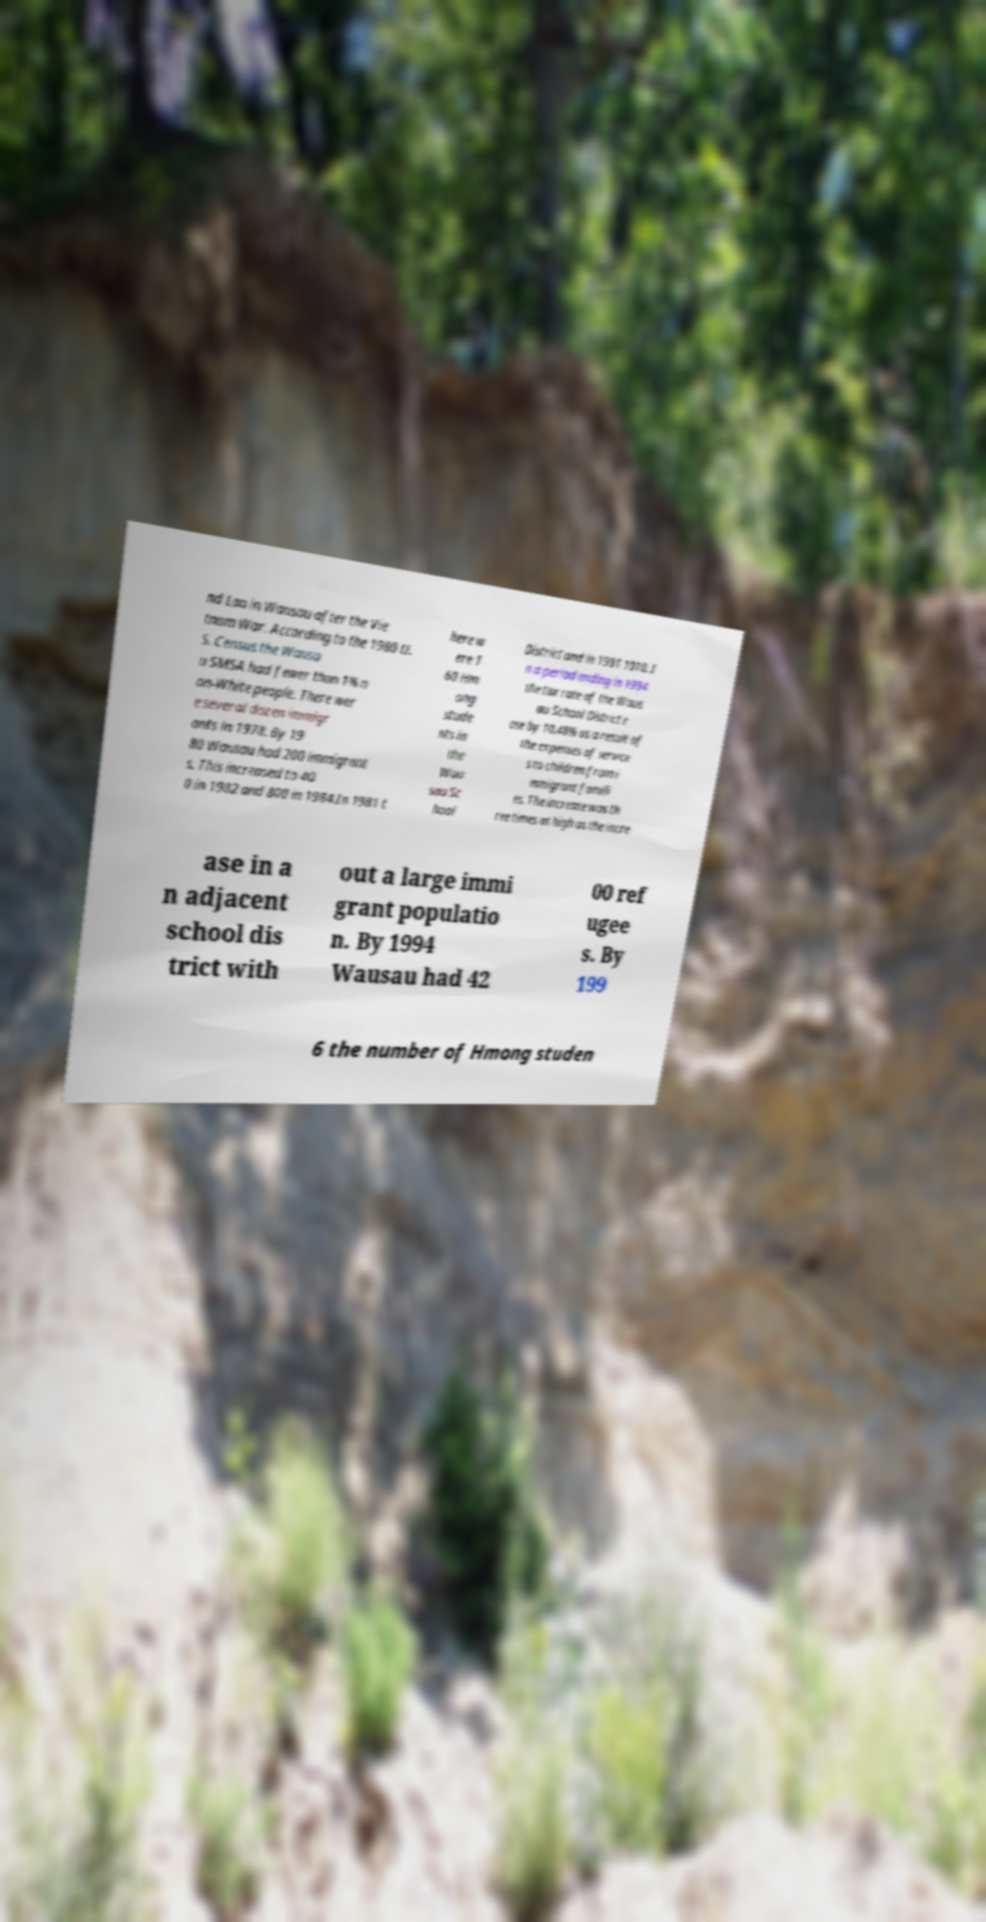Could you extract and type out the text from this image? nd Lao in Wausau after the Vie tnam War. According to the 1980 U. S. Census the Wausa u SMSA had fewer than 1% n on-White people. There wer e several dozen immigr ants in 1978. By 19 80 Wausau had 200 immigrant s. This increased to 40 0 in 1982 and 800 in 1984.In 1981 t here w ere 1 60 Hm ong stude nts in the Wau sau Sc hool District and in 1991 1010. I n a period ending in 1994 the tax rate of the Waus au School District r ose by 10.48% as a result of the expenses of service s to children from i mmigrant famili es. The increase was th ree times as high as the incre ase in a n adjacent school dis trict with out a large immi grant populatio n. By 1994 Wausau had 42 00 ref ugee s. By 199 6 the number of Hmong studen 